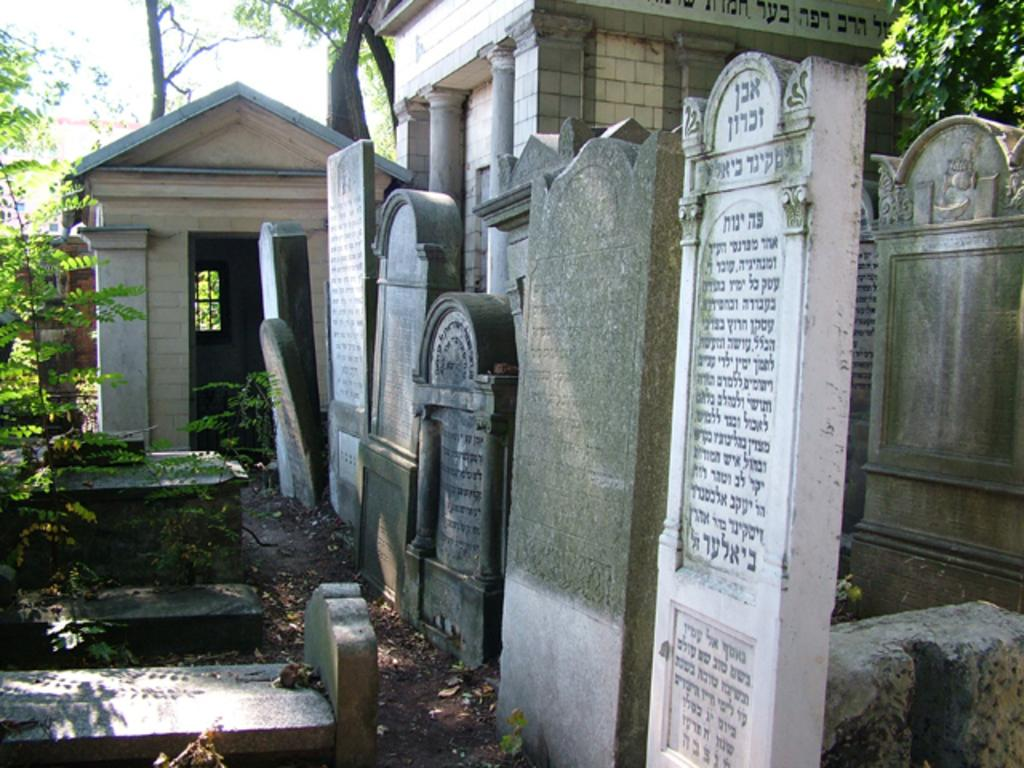What is the main subject of the image? The main subject of the image is graveyards. What can be seen on the left side of the image? There are trees on the left side of the image. What type of plant is being used as a hook in the image? There is no plant being used as a hook in the image. 